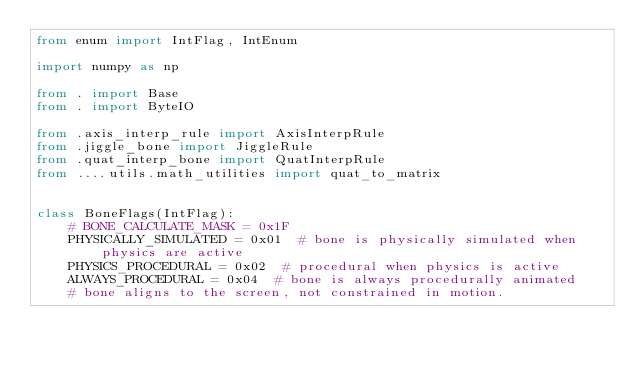<code> <loc_0><loc_0><loc_500><loc_500><_Python_>from enum import IntFlag, IntEnum

import numpy as np

from . import Base
from . import ByteIO

from .axis_interp_rule import AxisInterpRule
from .jiggle_bone import JiggleRule
from .quat_interp_bone import QuatInterpRule
from ....utils.math_utilities import quat_to_matrix


class BoneFlags(IntFlag):
    # BONE_CALCULATE_MASK = 0x1F
    PHYSICALLY_SIMULATED = 0x01  # bone is physically simulated when physics are active
    PHYSICS_PROCEDURAL = 0x02  # procedural when physics is active
    ALWAYS_PROCEDURAL = 0x04  # bone is always procedurally animated
    # bone aligns to the screen, not constrained in motion.</code> 